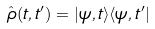<formula> <loc_0><loc_0><loc_500><loc_500>\hat { \rho } ( t , t ^ { \prime } ) = | \psi , t \rangle \langle \psi , t ^ { \prime } |</formula> 